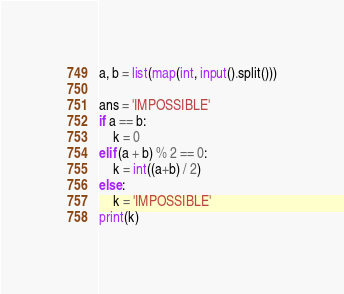<code> <loc_0><loc_0><loc_500><loc_500><_Python_>a, b = list(map(int, input().split()))

ans = 'IMPOSSIBLE'
if a == b:
    k = 0
elif (a + b) % 2 == 0:
    k = int((a+b) / 2)
else:
    k = 'IMPOSSIBLE'
print(k)</code> 